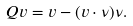<formula> <loc_0><loc_0><loc_500><loc_500>Q v = v - ( v \cdot \nu ) \nu .</formula> 